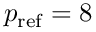Convert formula to latex. <formula><loc_0><loc_0><loc_500><loc_500>p _ { r e f } = 8</formula> 